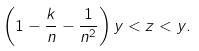<formula> <loc_0><loc_0><loc_500><loc_500>\left ( 1 - \frac { k } { n } - \frac { 1 } { n ^ { 2 } } \right ) y < z < y .</formula> 